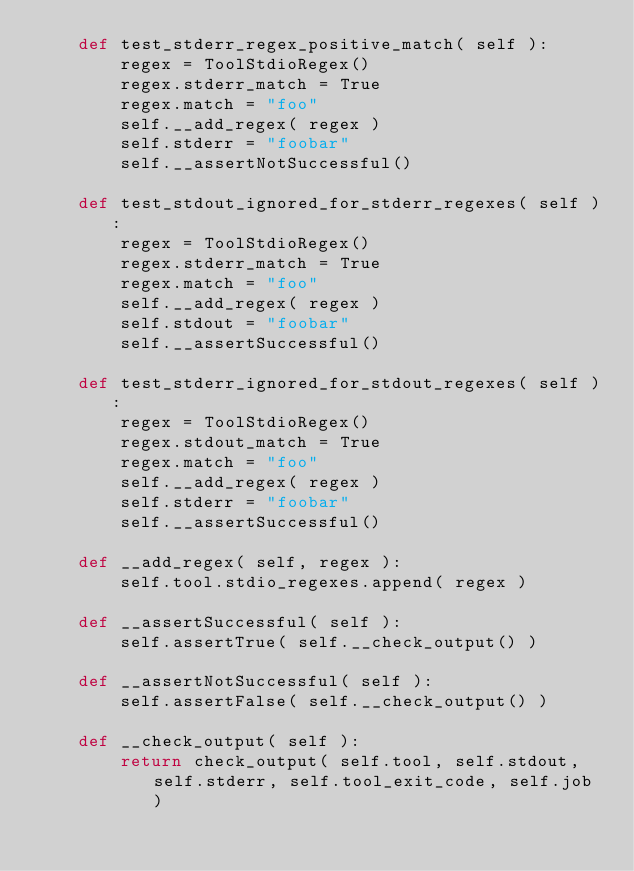Convert code to text. <code><loc_0><loc_0><loc_500><loc_500><_Python_>    def test_stderr_regex_positive_match( self ):
        regex = ToolStdioRegex()
        regex.stderr_match = True
        regex.match = "foo"
        self.__add_regex( regex )
        self.stderr = "foobar"
        self.__assertNotSuccessful()

    def test_stdout_ignored_for_stderr_regexes( self ):
        regex = ToolStdioRegex()
        regex.stderr_match = True
        regex.match = "foo"
        self.__add_regex( regex )
        self.stdout = "foobar"
        self.__assertSuccessful()

    def test_stderr_ignored_for_stdout_regexes( self ):
        regex = ToolStdioRegex()
        regex.stdout_match = True
        regex.match = "foo"
        self.__add_regex( regex )
        self.stderr = "foobar"
        self.__assertSuccessful()

    def __add_regex( self, regex ):
        self.tool.stdio_regexes.append( regex )

    def __assertSuccessful( self ):
        self.assertTrue( self.__check_output() )

    def __assertNotSuccessful( self ):
        self.assertFalse( self.__check_output() )

    def __check_output( self ):
        return check_output( self.tool, self.stdout, self.stderr, self.tool_exit_code, self.job )
</code> 